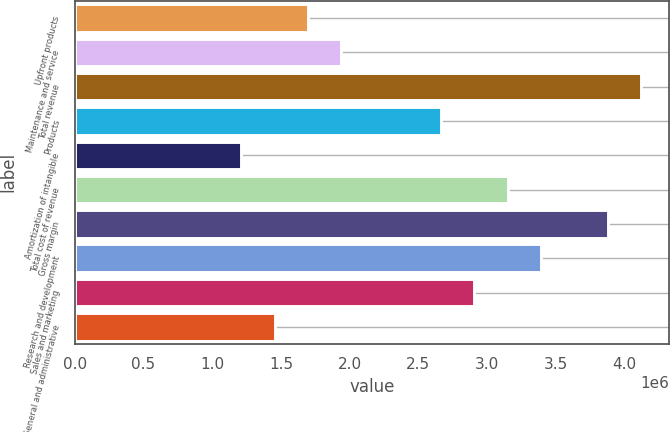<chart> <loc_0><loc_0><loc_500><loc_500><bar_chart><fcel>Upfront products<fcel>Maintenance and service<fcel>Total revenue<fcel>Products<fcel>Amortization of intangible<fcel>Total cost of revenue<fcel>Gross margin<fcel>Research and development<fcel>Sales and marketing<fcel>General and administrative<nl><fcel>1.69577e+06<fcel>1.93803e+06<fcel>4.1183e+06<fcel>2.66479e+06<fcel>1.21127e+06<fcel>3.14929e+06<fcel>3.87605e+06<fcel>3.39154e+06<fcel>2.90704e+06<fcel>1.45352e+06<nl></chart> 